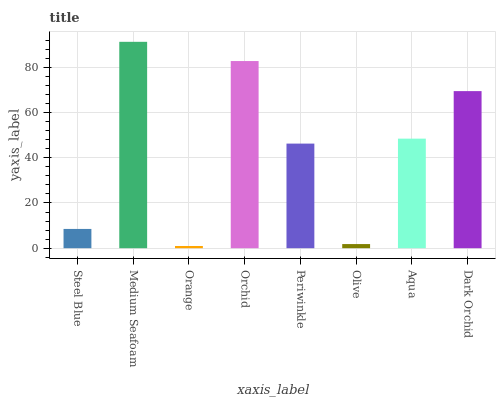Is Orange the minimum?
Answer yes or no. Yes. Is Medium Seafoam the maximum?
Answer yes or no. Yes. Is Medium Seafoam the minimum?
Answer yes or no. No. Is Orange the maximum?
Answer yes or no. No. Is Medium Seafoam greater than Orange?
Answer yes or no. Yes. Is Orange less than Medium Seafoam?
Answer yes or no. Yes. Is Orange greater than Medium Seafoam?
Answer yes or no. No. Is Medium Seafoam less than Orange?
Answer yes or no. No. Is Aqua the high median?
Answer yes or no. Yes. Is Periwinkle the low median?
Answer yes or no. Yes. Is Orange the high median?
Answer yes or no. No. Is Orchid the low median?
Answer yes or no. No. 